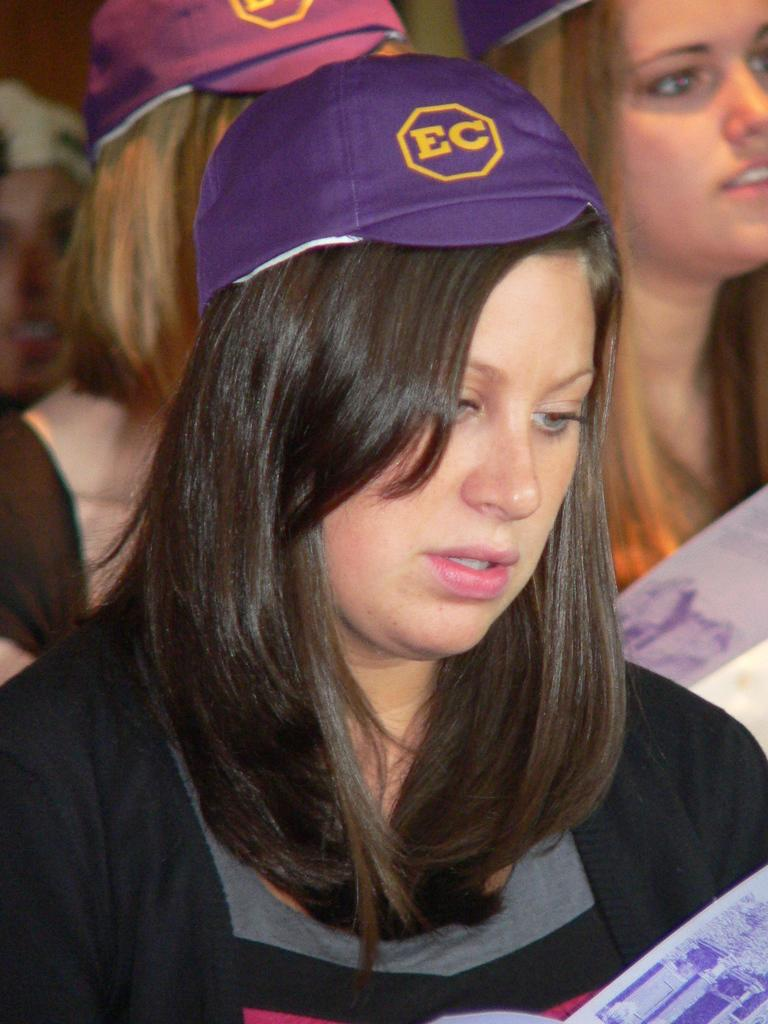Provide a one-sentence caption for the provided image. A young woman in a crowd, wearing a purple EC hat. 